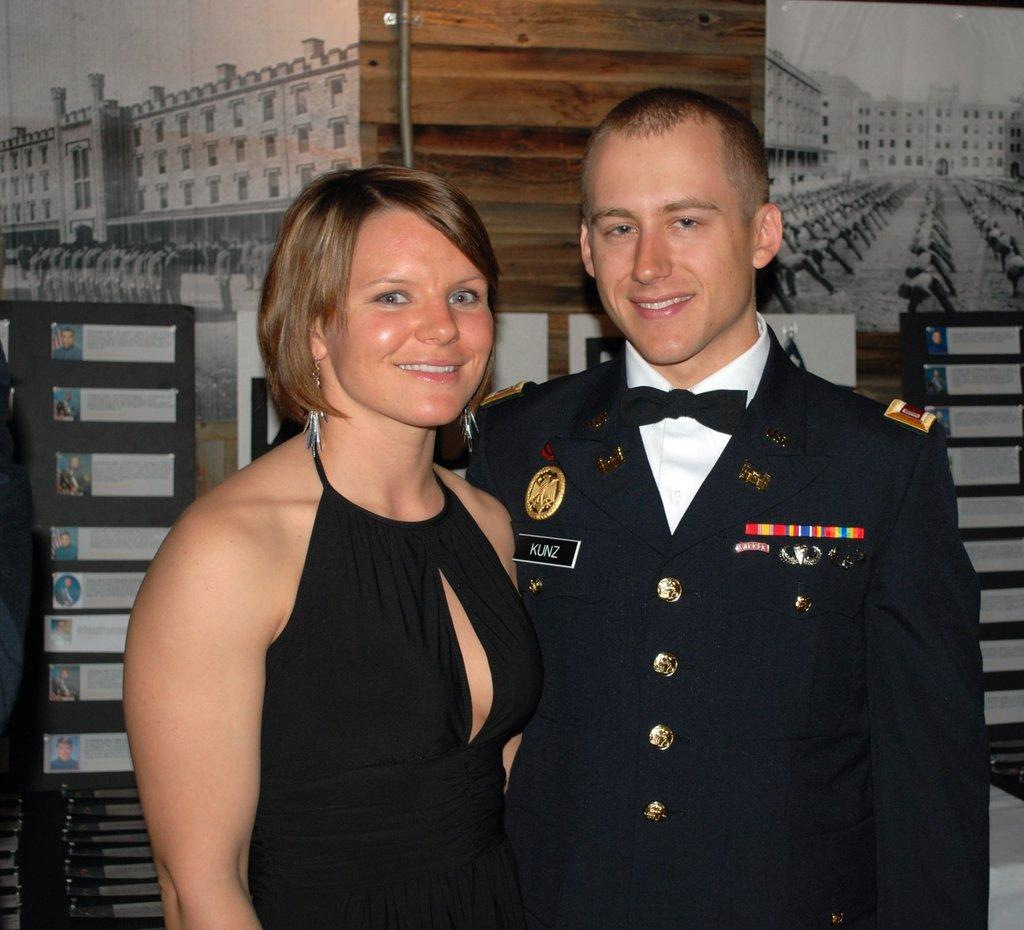What is the gender of the person in the image wearing a black dress? There are two people in the image wearing black dresses, a man and a woman. What color are the dresses worn by the people in the image? The dresses worn by the people in the image are black. What can be seen in the background of the image? There is a wall in the background of the image, and there are posters on the wall. Can you tell me the total cost of the items listed on the receipt in the image? There is no receipt present in the image, so it is not possible to determine the total cost of any items. 